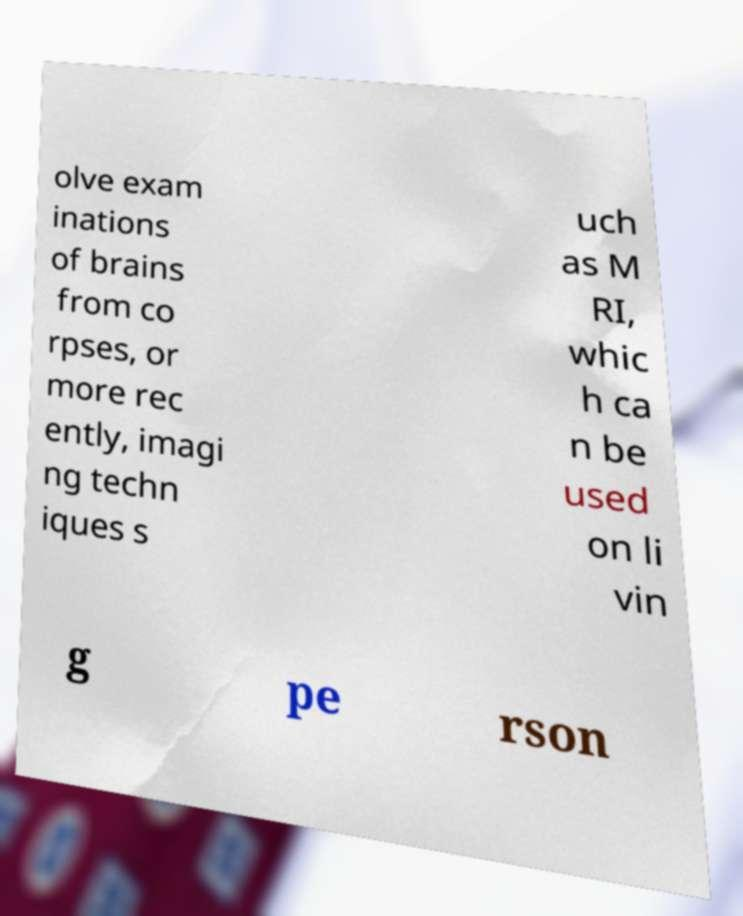Could you extract and type out the text from this image? olve exam inations of brains from co rpses, or more rec ently, imagi ng techn iques s uch as M RI, whic h ca n be used on li vin g pe rson 